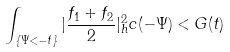<formula> <loc_0><loc_0><loc_500><loc_500>\int _ { \{ \Psi < - t \} } | \frac { f _ { 1 } + f _ { 2 } } { 2 } | ^ { 2 } _ { h } c ( - \Psi ) < G ( t )</formula> 